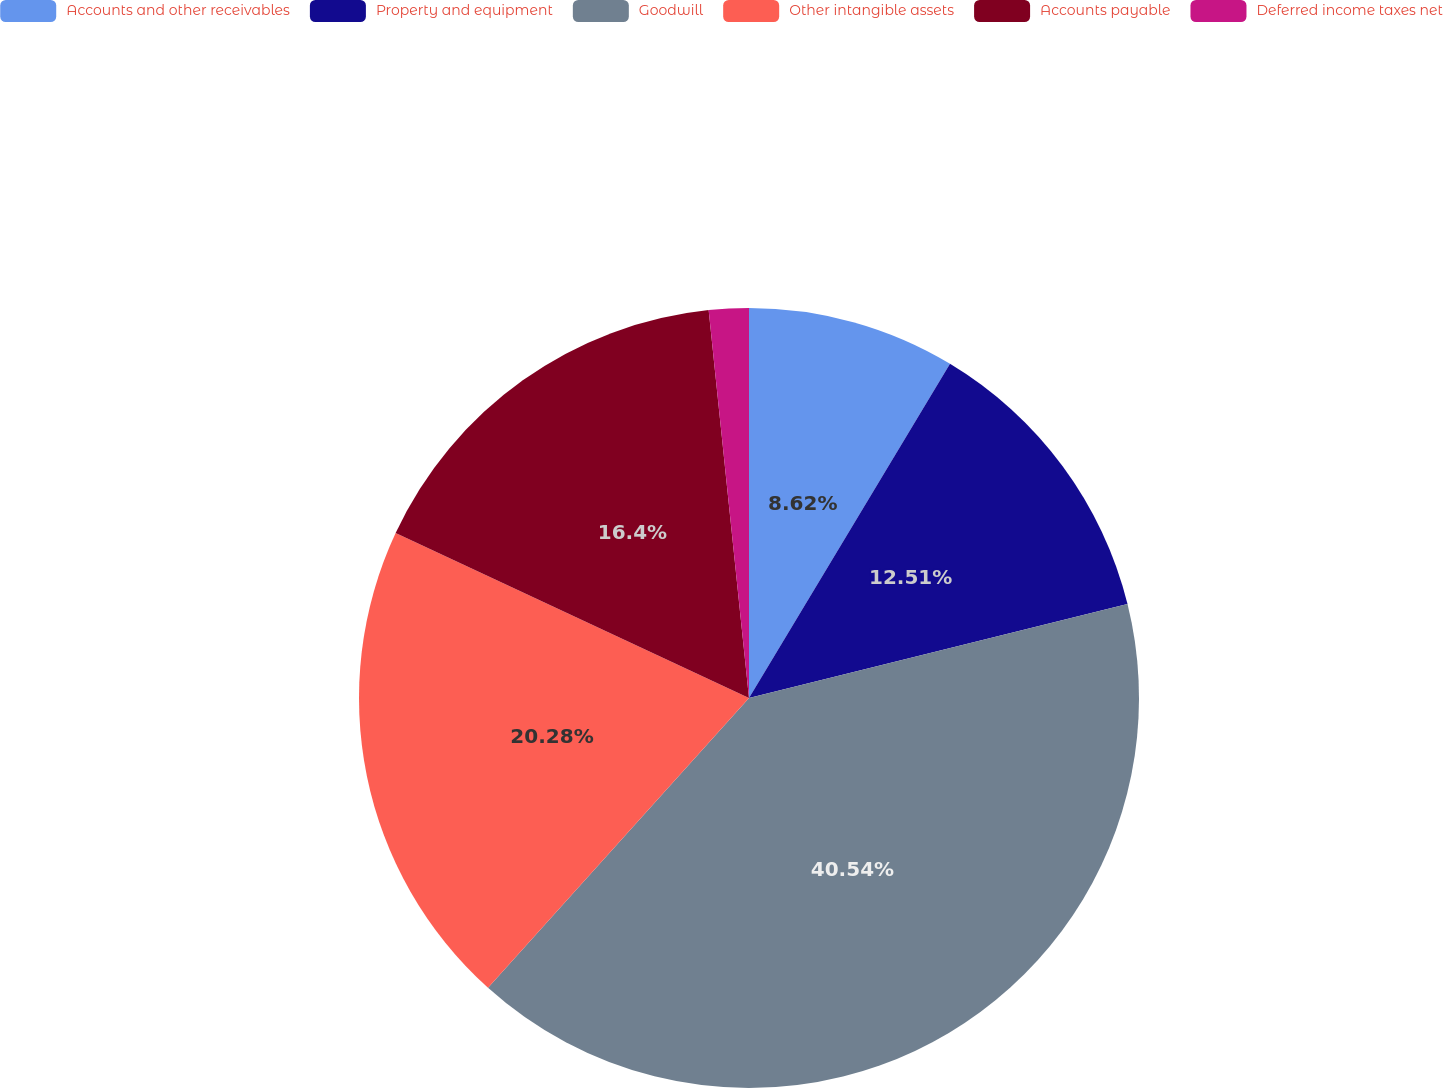Convert chart to OTSL. <chart><loc_0><loc_0><loc_500><loc_500><pie_chart><fcel>Accounts and other receivables<fcel>Property and equipment<fcel>Goodwill<fcel>Other intangible assets<fcel>Accounts payable<fcel>Deferred income taxes net<nl><fcel>8.62%<fcel>12.51%<fcel>40.55%<fcel>20.29%<fcel>16.4%<fcel>1.65%<nl></chart> 